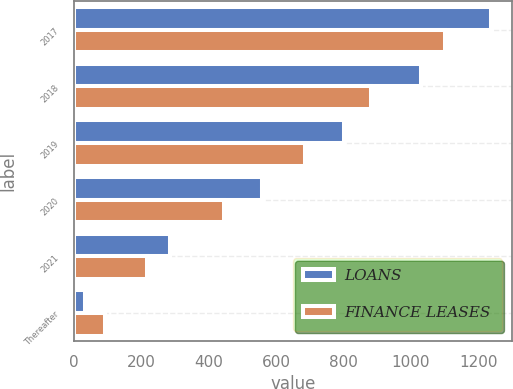<chart> <loc_0><loc_0><loc_500><loc_500><stacked_bar_chart><ecel><fcel>2017<fcel>2018<fcel>2019<fcel>2020<fcel>2021<fcel>Thereafter<nl><fcel>LOANS<fcel>1238.4<fcel>1030.4<fcel>802.2<fcel>557.8<fcel>285<fcel>34.8<nl><fcel>FINANCE LEASES<fcel>1101.8<fcel>882<fcel>684.6<fcel>446.5<fcel>217<fcel>94.3<nl></chart> 